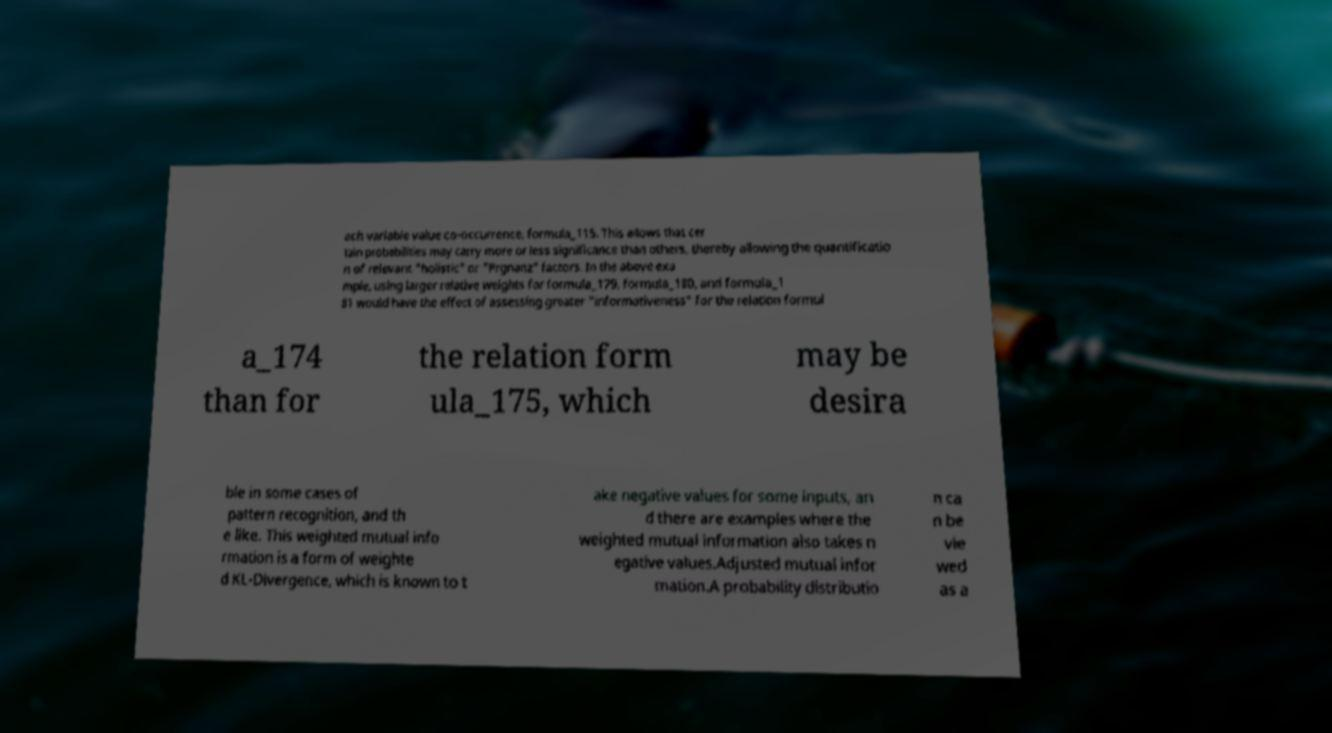What messages or text are displayed in this image? I need them in a readable, typed format. ach variable value co-occurrence, formula_115. This allows that cer tain probabilities may carry more or less significance than others, thereby allowing the quantificatio n of relevant "holistic" or "Prgnanz" factors. In the above exa mple, using larger relative weights for formula_179, formula_180, and formula_1 81 would have the effect of assessing greater "informativeness" for the relation formul a_174 than for the relation form ula_175, which may be desira ble in some cases of pattern recognition, and th e like. This weighted mutual info rmation is a form of weighte d KL-Divergence, which is known to t ake negative values for some inputs, an d there are examples where the weighted mutual information also takes n egative values.Adjusted mutual infor mation.A probability distributio n ca n be vie wed as a 